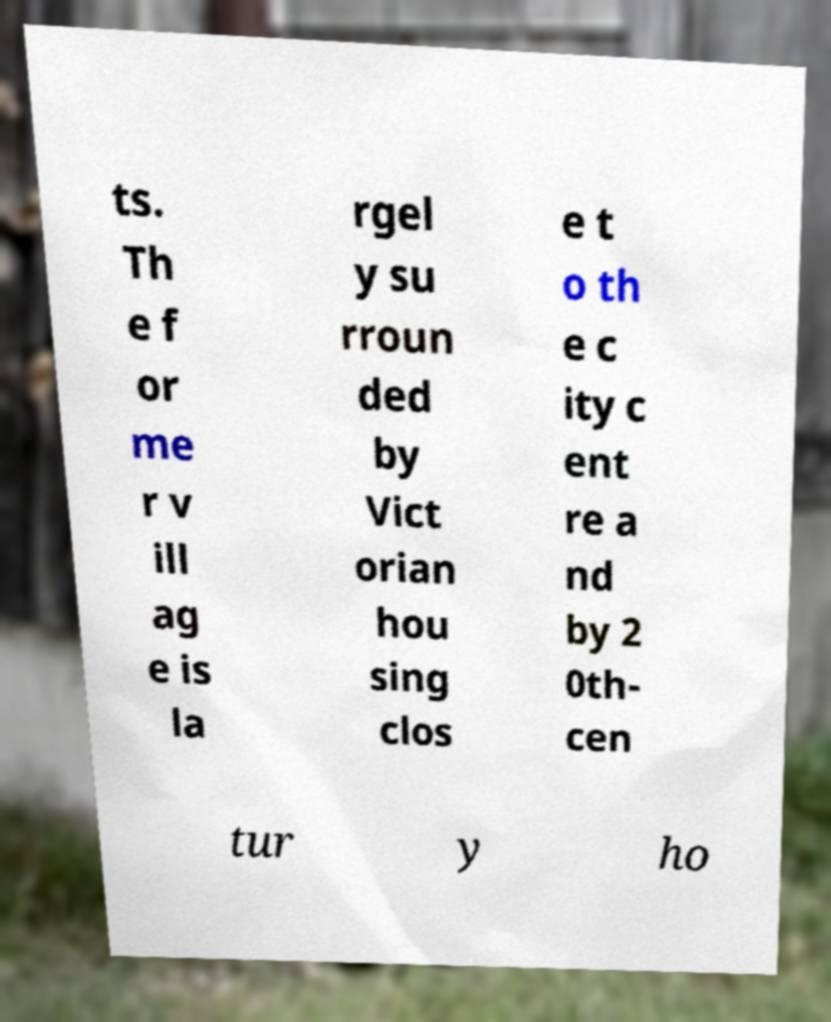For documentation purposes, I need the text within this image transcribed. Could you provide that? ts. Th e f or me r v ill ag e is la rgel y su rroun ded by Vict orian hou sing clos e t o th e c ity c ent re a nd by 2 0th- cen tur y ho 